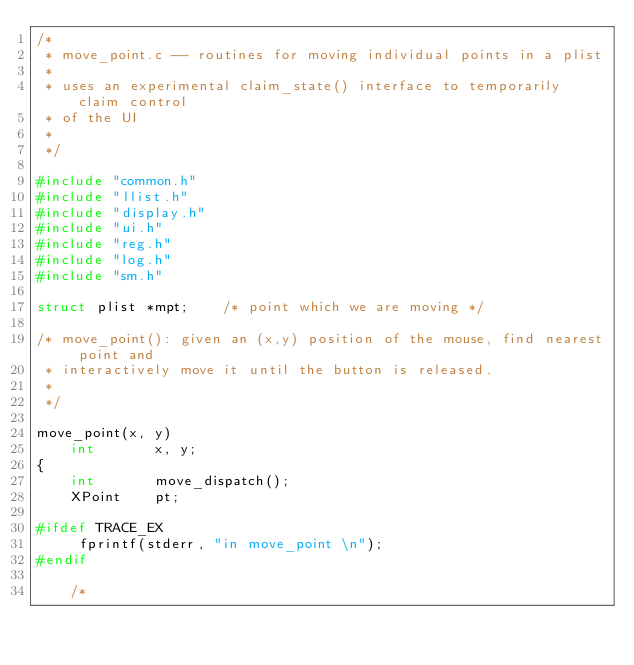Convert code to text. <code><loc_0><loc_0><loc_500><loc_500><_C_>/*
 * move_point.c -- routines for moving individual points in a plist
 *
 * uses an experimental claim_state() interface to temporarily claim control
 * of the UI
 *
 */

#include "common.h"
#include "llist.h"
#include "display.h"
#include "ui.h"
#include "reg.h"
#include "log.h"
#include "sm.h"

struct plist *mpt;		/* point which we are moving */

/* move_point(): given an (x,y) position of the mouse, find nearest point and
 * interactively move it until the button is released.
 *
 */

move_point(x, y)
    int       x, y;
{
    int       move_dispatch();
    XPoint    pt;

#ifdef TRACE_EX
     fprintf(stderr, "in move_point \n");
#endif

    /*</code> 